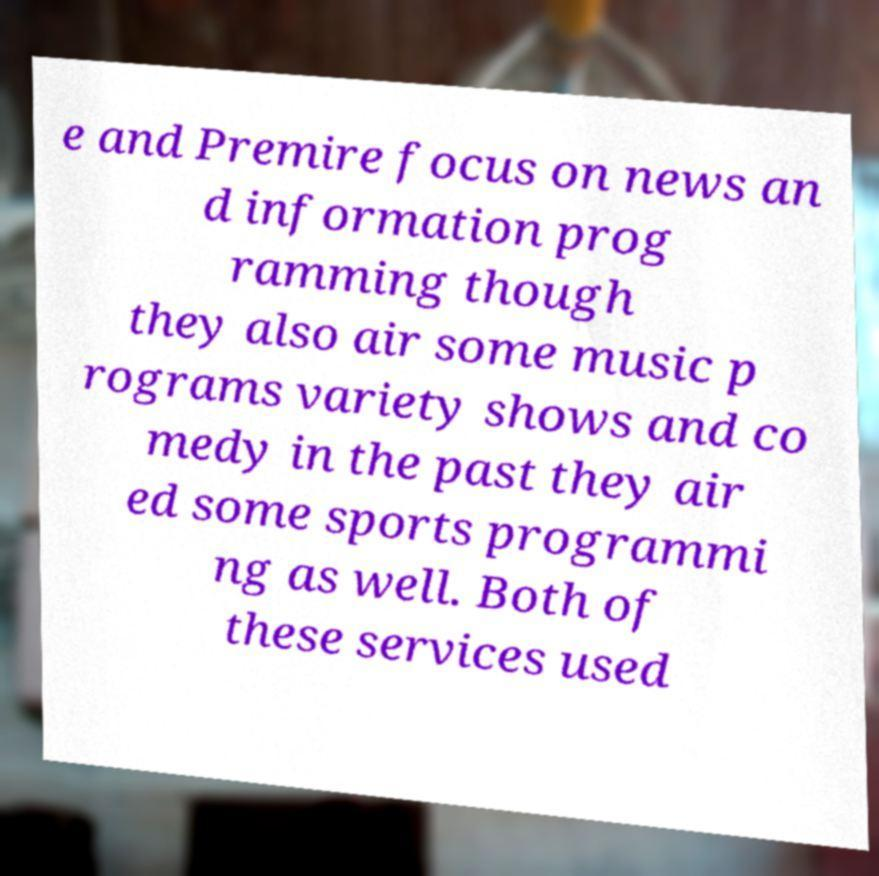Please identify and transcribe the text found in this image. e and Premire focus on news an d information prog ramming though they also air some music p rograms variety shows and co medy in the past they air ed some sports programmi ng as well. Both of these services used 